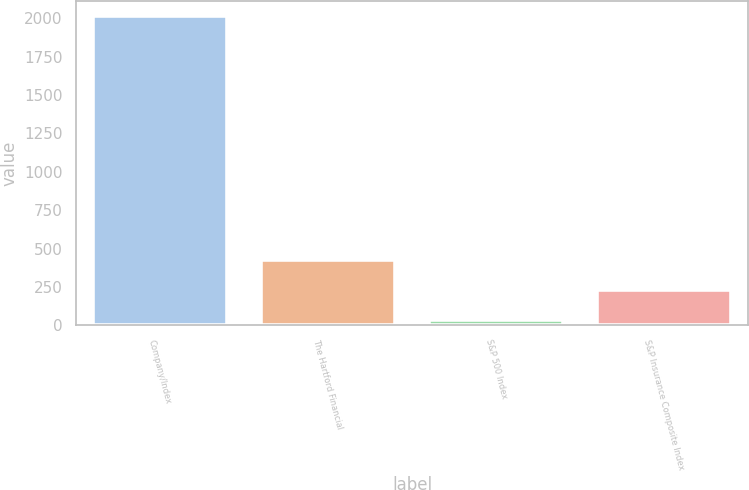Convert chart to OTSL. <chart><loc_0><loc_0><loc_500><loc_500><bar_chart><fcel>Company/Index<fcel>The Hartford Financial<fcel>S&P 500 Index<fcel>S&P Insurance Composite Index<nl><fcel>2013<fcel>428.51<fcel>32.39<fcel>230.45<nl></chart> 